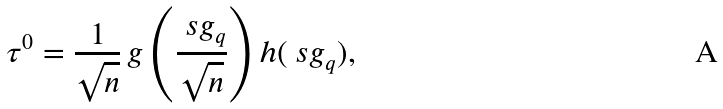Convert formula to latex. <formula><loc_0><loc_0><loc_500><loc_500>\tau ^ { 0 } = \frac { 1 } { \sqrt { n } } \, g \left ( \frac { \ s g _ { q } } { \sqrt { n } } \right ) h ( \ s g _ { q } ) ,</formula> 